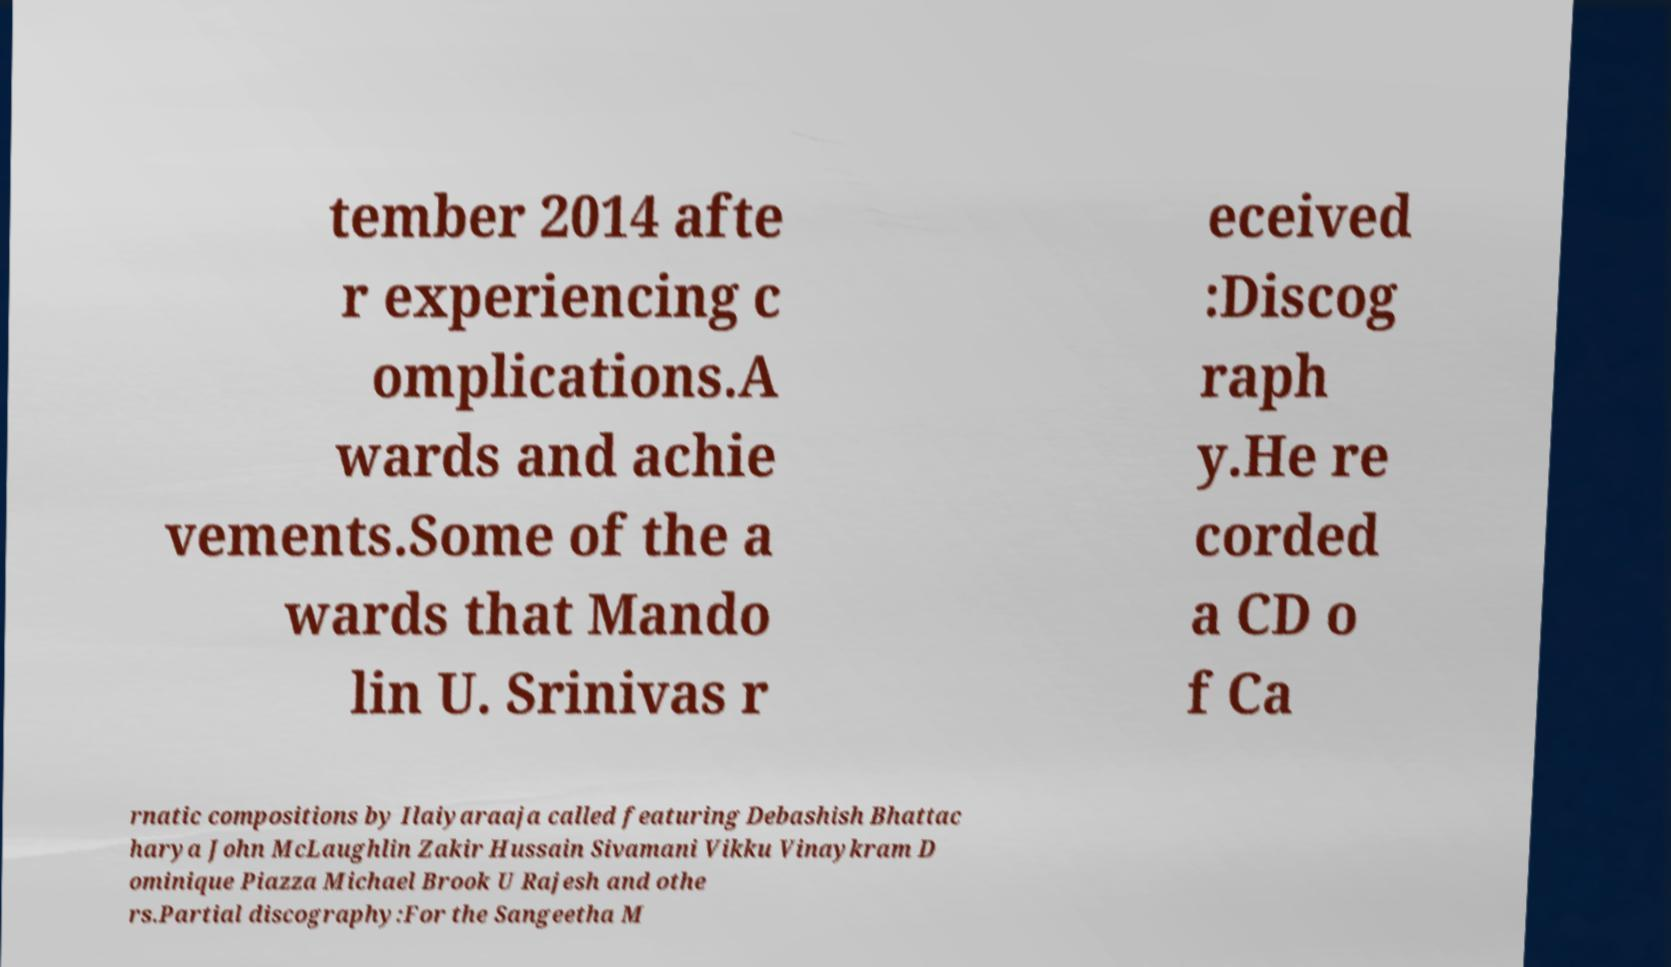What messages or text are displayed in this image? I need them in a readable, typed format. tember 2014 afte r experiencing c omplications.A wards and achie vements.Some of the a wards that Mando lin U. Srinivas r eceived :Discog raph y.He re corded a CD o f Ca rnatic compositions by Ilaiyaraaja called featuring Debashish Bhattac harya John McLaughlin Zakir Hussain Sivamani Vikku Vinaykram D ominique Piazza Michael Brook U Rajesh and othe rs.Partial discography:For the Sangeetha M 